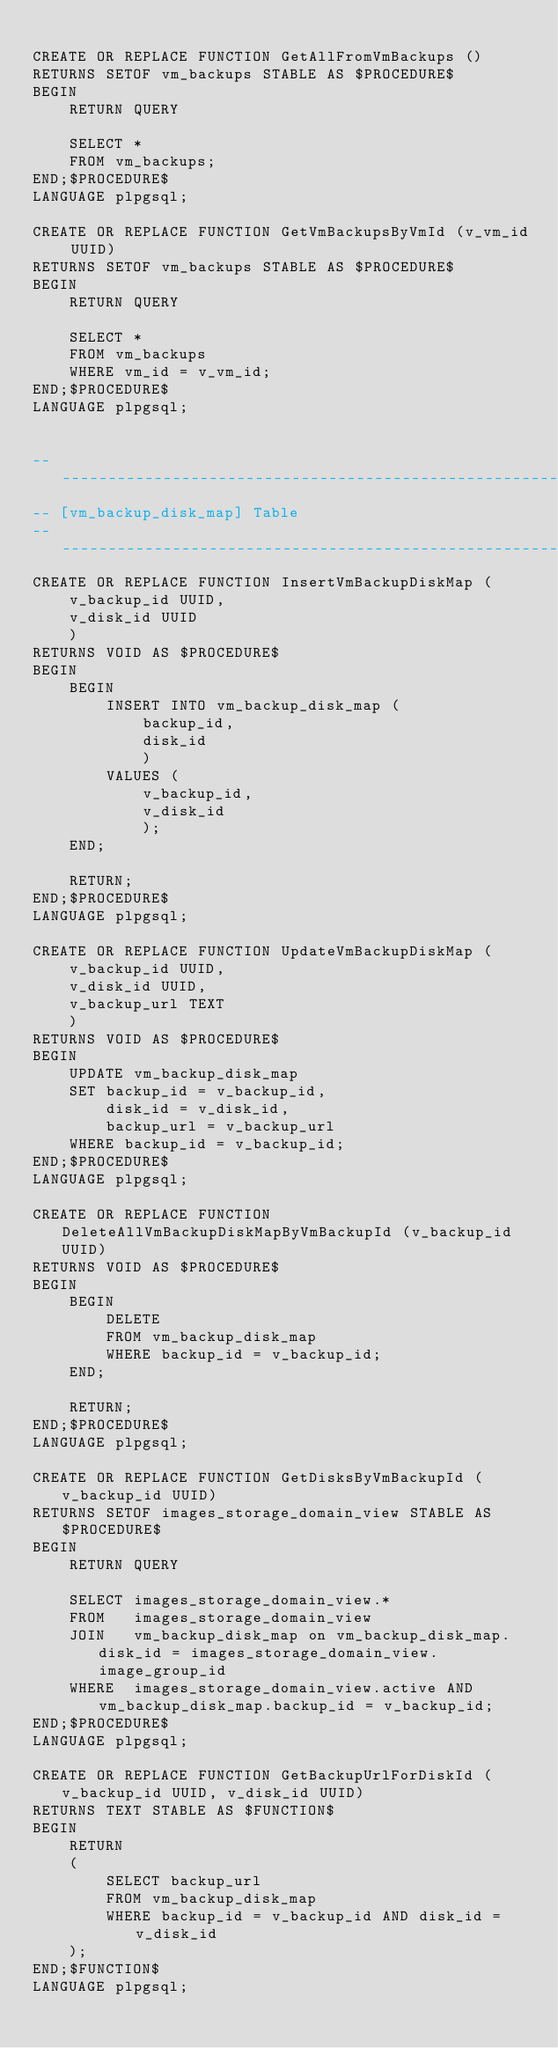Convert code to text. <code><loc_0><loc_0><loc_500><loc_500><_SQL_>
CREATE OR REPLACE FUNCTION GetAllFromVmBackups ()
RETURNS SETOF vm_backups STABLE AS $PROCEDURE$
BEGIN
    RETURN QUERY

    SELECT *
    FROM vm_backups;
END;$PROCEDURE$
LANGUAGE plpgsql;

CREATE OR REPLACE FUNCTION GetVmBackupsByVmId (v_vm_id UUID)
RETURNS SETOF vm_backups STABLE AS $PROCEDURE$
BEGIN
    RETURN QUERY

    SELECT *
    FROM vm_backups
    WHERE vm_id = v_vm_id;
END;$PROCEDURE$
LANGUAGE plpgsql;


----------------------------------------------------------------
-- [vm_backup_disk_map] Table
----------------------------------------------------------------------
CREATE OR REPLACE FUNCTION InsertVmBackupDiskMap (
    v_backup_id UUID,
    v_disk_id UUID
    )
RETURNS VOID AS $PROCEDURE$
BEGIN
    BEGIN
        INSERT INTO vm_backup_disk_map (
            backup_id,
            disk_id
            )
        VALUES (
            v_backup_id,
            v_disk_id
            );
    END;

    RETURN;
END;$PROCEDURE$
LANGUAGE plpgsql;

CREATE OR REPLACE FUNCTION UpdateVmBackupDiskMap (
    v_backup_id UUID,
    v_disk_id UUID,
    v_backup_url TEXT
    )
RETURNS VOID AS $PROCEDURE$
BEGIN
    UPDATE vm_backup_disk_map
    SET backup_id = v_backup_id,
        disk_id = v_disk_id,
        backup_url = v_backup_url
    WHERE backup_id = v_backup_id;
END;$PROCEDURE$
LANGUAGE plpgsql;

CREATE OR REPLACE FUNCTION DeleteAllVmBackupDiskMapByVmBackupId (v_backup_id UUID)
RETURNS VOID AS $PROCEDURE$
BEGIN
    BEGIN
        DELETE
        FROM vm_backup_disk_map
        WHERE backup_id = v_backup_id;
    END;

    RETURN;
END;$PROCEDURE$
LANGUAGE plpgsql;

CREATE OR REPLACE FUNCTION GetDisksByVmBackupId (v_backup_id UUID)
RETURNS SETOF images_storage_domain_view STABLE AS $PROCEDURE$
BEGIN
    RETURN QUERY

    SELECT images_storage_domain_view.*
    FROM   images_storage_domain_view
    JOIN   vm_backup_disk_map on vm_backup_disk_map.disk_id = images_storage_domain_view.image_group_id
    WHERE  images_storage_domain_view.active AND vm_backup_disk_map.backup_id = v_backup_id;
END;$PROCEDURE$
LANGUAGE plpgsql;

CREATE OR REPLACE FUNCTION GetBackupUrlForDiskId (v_backup_id UUID, v_disk_id UUID)
RETURNS TEXT STABLE AS $FUNCTION$
BEGIN
    RETURN
    (
        SELECT backup_url
        FROM vm_backup_disk_map
        WHERE backup_id = v_backup_id AND disk_id = v_disk_id
    );
END;$FUNCTION$
LANGUAGE plpgsql;
</code> 